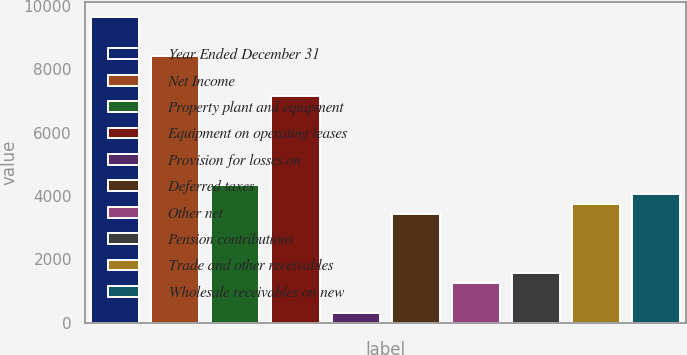Convert chart. <chart><loc_0><loc_0><loc_500><loc_500><bar_chart><fcel>Year Ended December 31<fcel>Net Income<fcel>Property plant and equipment<fcel>Equipment on operating leases<fcel>Provision for losses on<fcel>Deferred taxes<fcel>Other net<fcel>Pension contributions<fcel>Trade and other receivables<fcel>Wholesale receivables on new<nl><fcel>9651.16<fcel>8406.52<fcel>4361.44<fcel>7161.88<fcel>316.36<fcel>3427.96<fcel>1249.84<fcel>1561<fcel>3739.12<fcel>4050.28<nl></chart> 